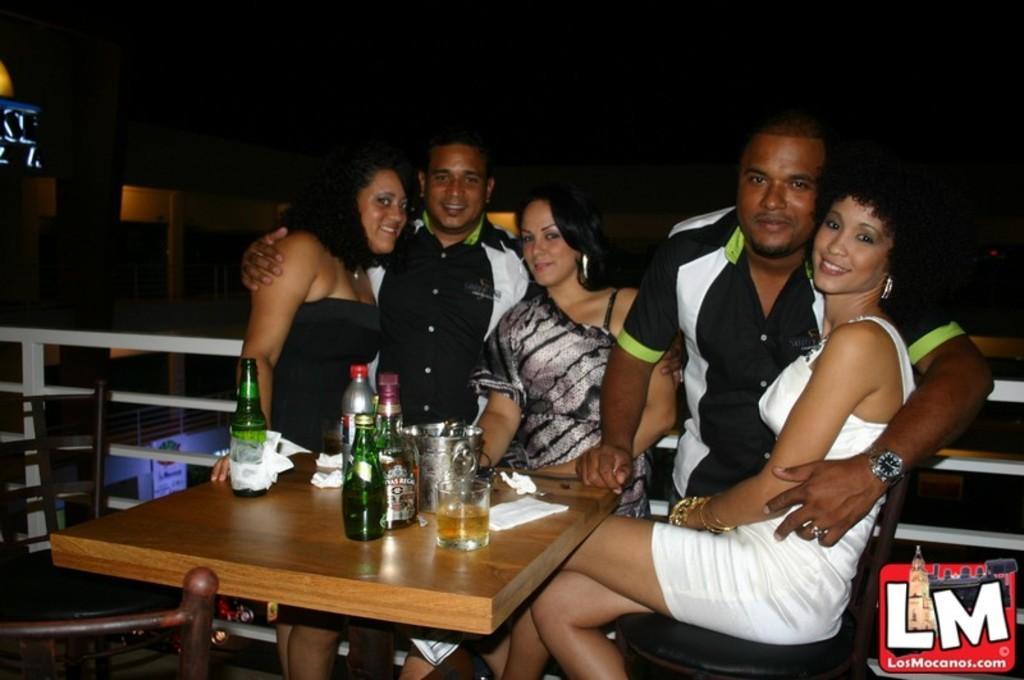Can you describe this image briefly? In this image we can see five persons and they are all smiling. This is a table where a wine bottle , a glass and tissues are kept on it. Here we can see chairs on the left side. 